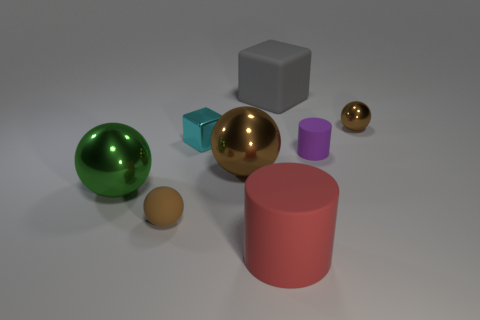Subtract all cyan cylinders. How many brown spheres are left? 3 Add 1 small things. How many objects exist? 9 Subtract all cubes. How many objects are left? 6 Add 7 big yellow matte cylinders. How many big yellow matte cylinders exist? 7 Subtract 0 yellow cubes. How many objects are left? 8 Subtract all small brown objects. Subtract all rubber cylinders. How many objects are left? 4 Add 1 purple rubber objects. How many purple rubber objects are left? 2 